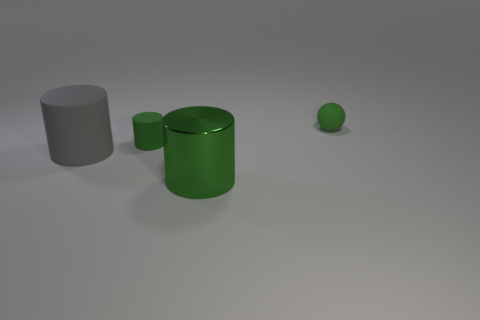Subtract all big cylinders. How many cylinders are left? 1 Add 3 yellow metallic cylinders. How many objects exist? 7 Subtract all gray cylinders. How many cylinders are left? 2 Subtract all cyan balls. How many green cylinders are left? 2 Subtract all balls. How many objects are left? 3 Add 3 tiny gray things. How many tiny gray things exist? 3 Subtract 0 green blocks. How many objects are left? 4 Subtract all blue balls. Subtract all red cylinders. How many balls are left? 1 Subtract all large yellow cylinders. Subtract all shiny cylinders. How many objects are left? 3 Add 2 tiny green objects. How many tiny green objects are left? 4 